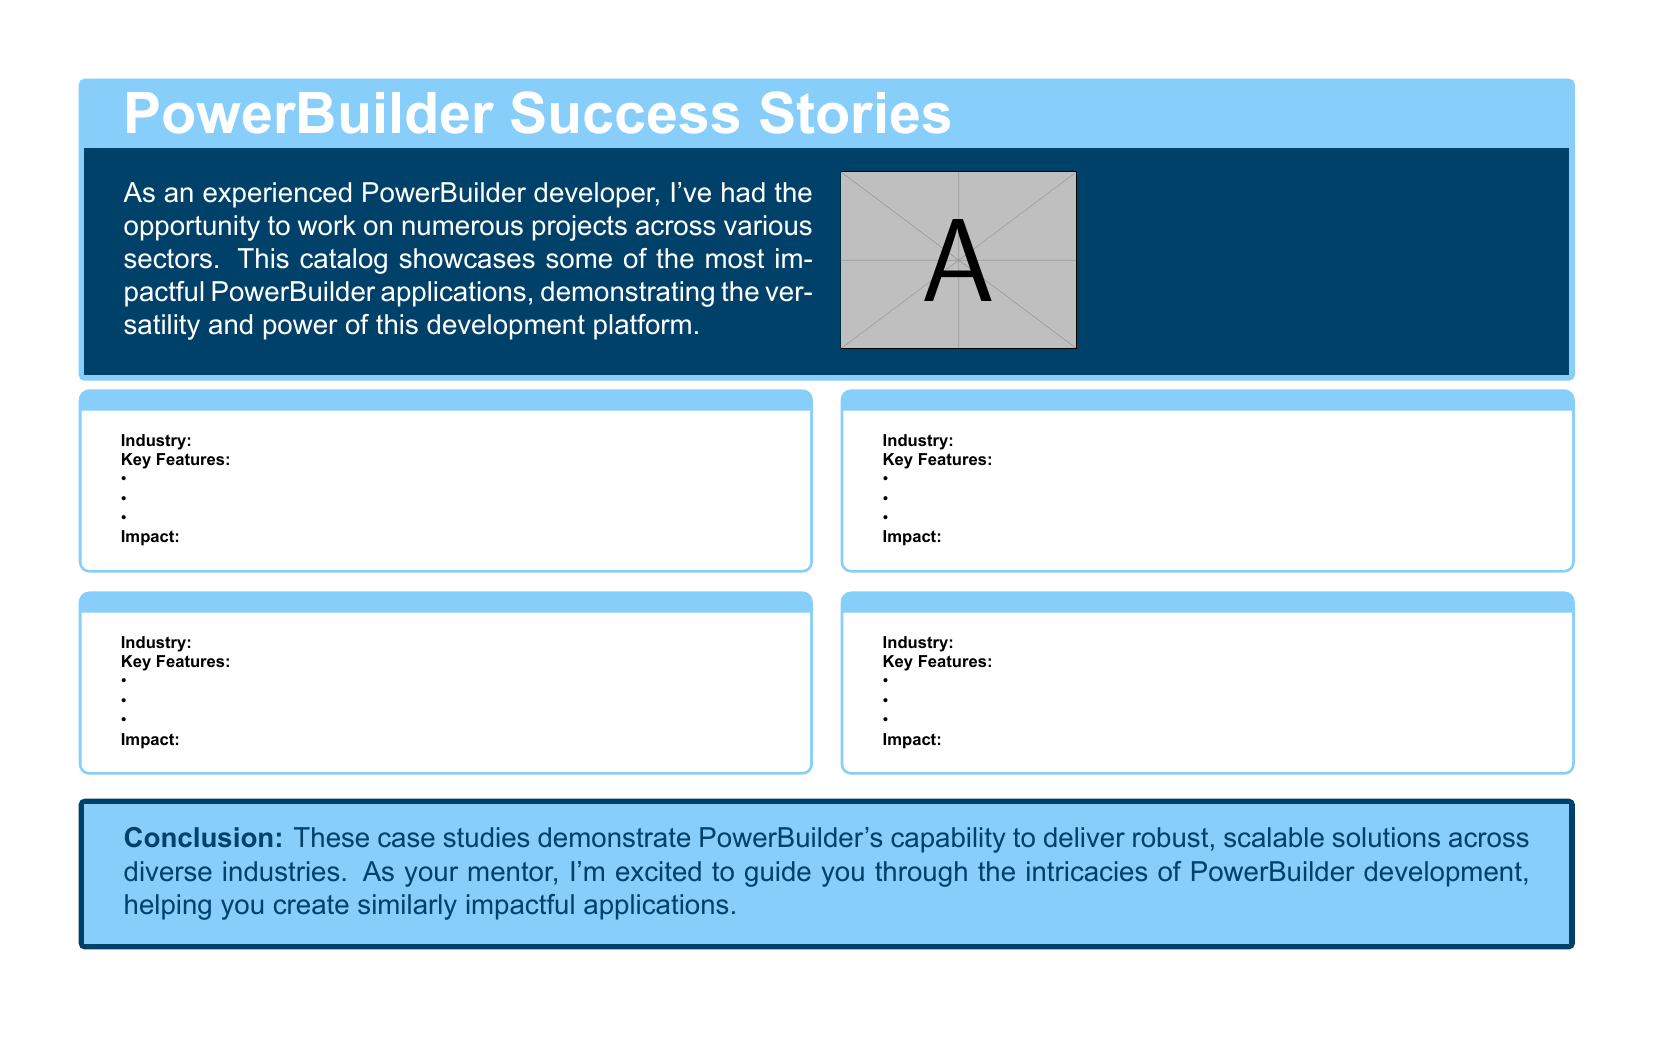What is the title of the document? The title of the document is the heading of the main box, which states "PowerBuilder Success Stories".
Answer: PowerBuilder Success Stories How many case studies are showcased in the document? The document includes four case studies as indicated by the loop in the code.
Answer: 4 What is the color of the box background for the case studies? The case study boxes have a background color specified as white in the code.
Answer: White What is the primary industry mentioned in case study 1? The specific industry is noted under the "Industry" section of case study 1.
Answer: [To be filled by actual content] What is the impact highlighted for the case studies? The document states that these case studies demonstrate PowerBuilder's capability to deliver robust, scalable solutions.
Answer: Robust, scalable solutions What type of applications does the catalog feature? The document mentions various PowerBuilder applications, showcasing their versatility and power in development.
Answer: PowerBuilder applications What key feature is listed first in each case study? The key features are enumerated, with the first one being the first item in the bulleted list under each case study.
Answer: [To be filled by actual content] What is the conclusion regarding PowerBuilder's capabilities? The conclusion expresses excitement about guiding through PowerBuilder development, emphasizing its capability.
Answer: Capability to deliver robust, scalable solutions What font is used in the document? The document specifies the main font as Arial.
Answer: Arial 